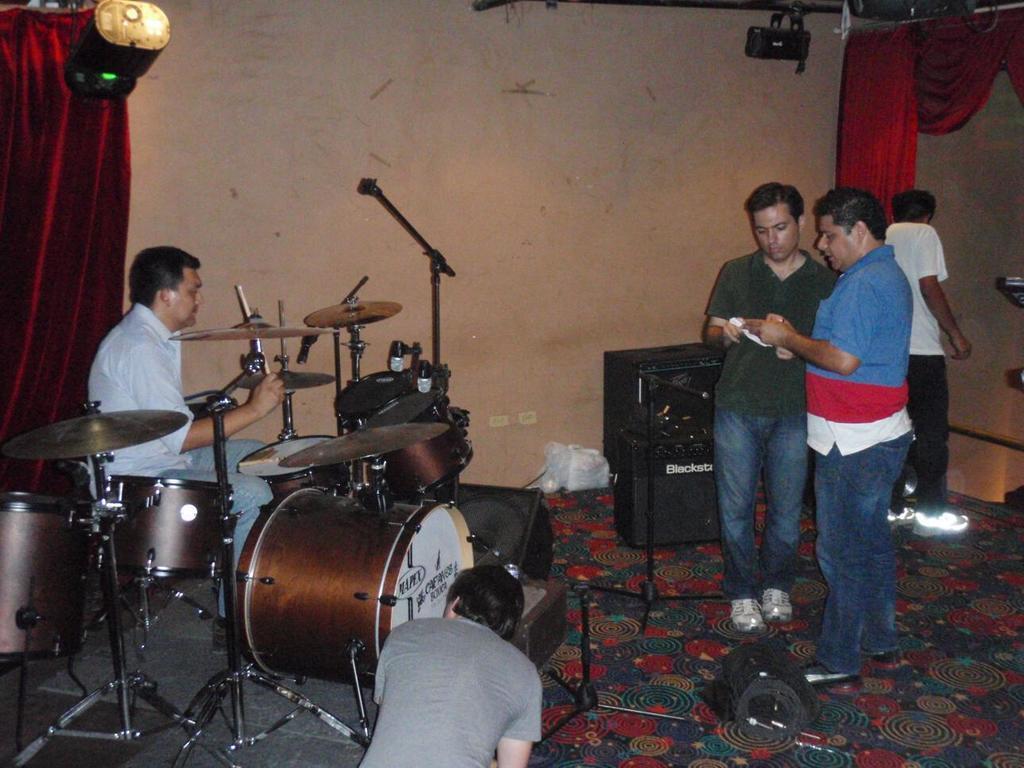Can you describe this image briefly? In this image we can see this person is playing electronic drums. This people are standing. In the background we can see curtain, speaker, wall and show lights. 